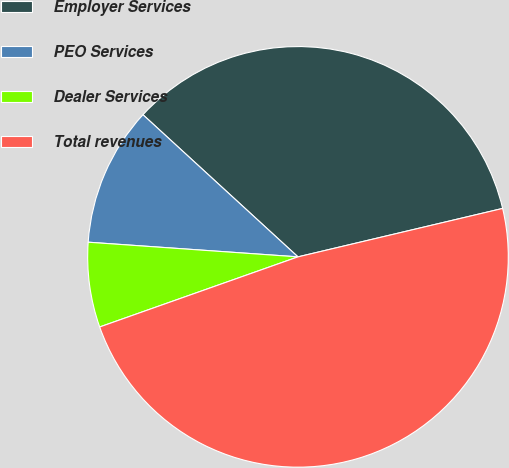<chart> <loc_0><loc_0><loc_500><loc_500><pie_chart><fcel>Employer Services<fcel>PEO Services<fcel>Dealer Services<fcel>Total revenues<nl><fcel>34.49%<fcel>10.7%<fcel>6.52%<fcel>48.29%<nl></chart> 